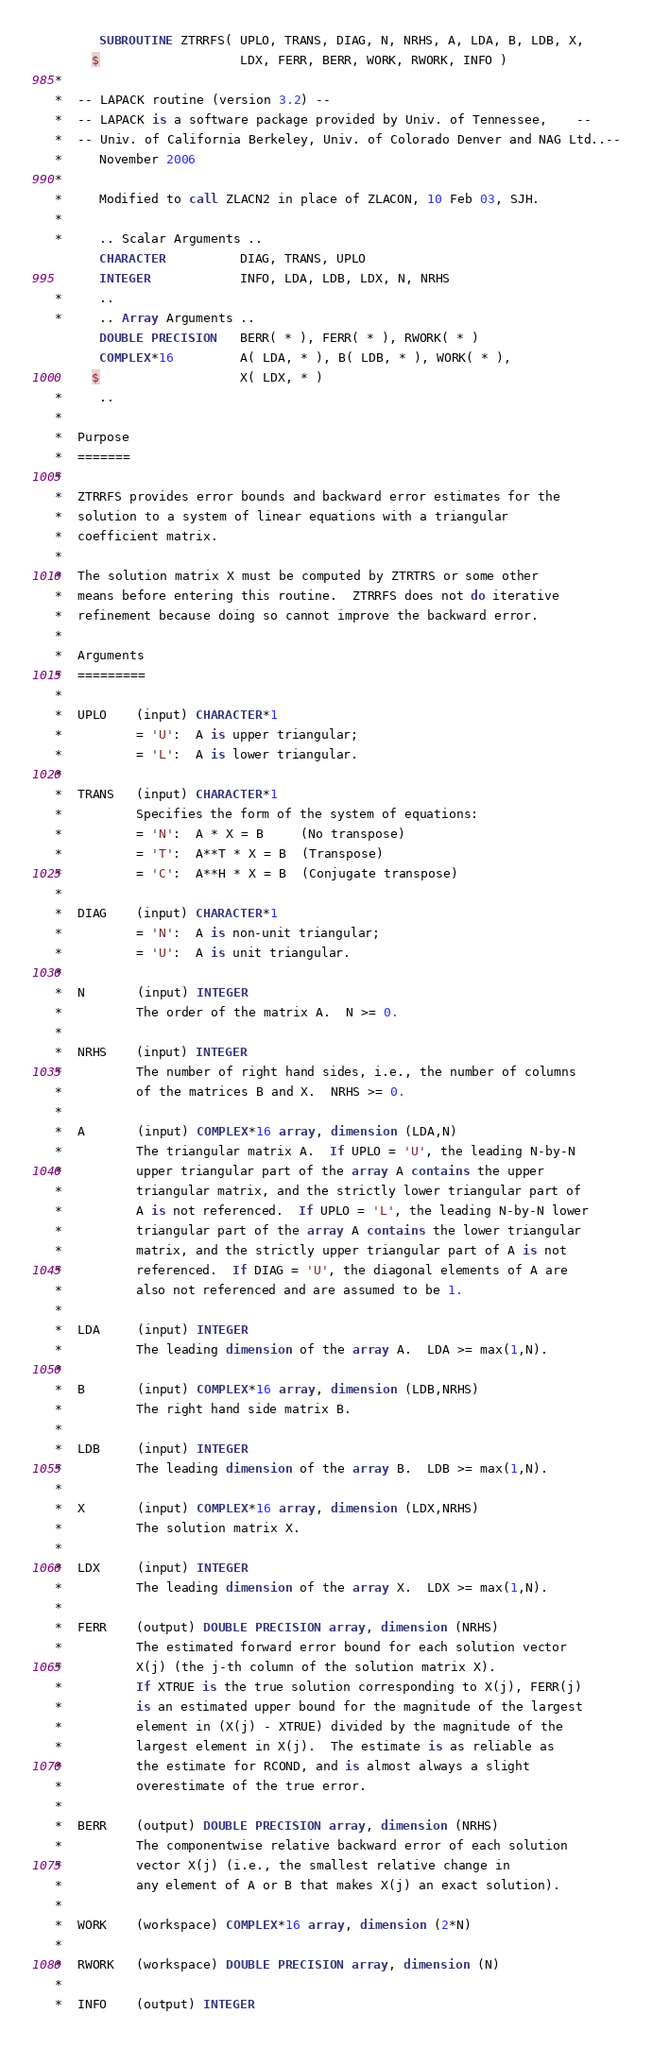Convert code to text. <code><loc_0><loc_0><loc_500><loc_500><_FORTRAN_>      SUBROUTINE ZTRRFS( UPLO, TRANS, DIAG, N, NRHS, A, LDA, B, LDB, X,
     $                   LDX, FERR, BERR, WORK, RWORK, INFO )
*
*  -- LAPACK routine (version 3.2) --
*  -- LAPACK is a software package provided by Univ. of Tennessee,    --
*  -- Univ. of California Berkeley, Univ. of Colorado Denver and NAG Ltd..--
*     November 2006
*
*     Modified to call ZLACN2 in place of ZLACON, 10 Feb 03, SJH.
*
*     .. Scalar Arguments ..
      CHARACTER          DIAG, TRANS, UPLO
      INTEGER            INFO, LDA, LDB, LDX, N, NRHS
*     ..
*     .. Array Arguments ..
      DOUBLE PRECISION   BERR( * ), FERR( * ), RWORK( * )
      COMPLEX*16         A( LDA, * ), B( LDB, * ), WORK( * ),
     $                   X( LDX, * )
*     ..
*
*  Purpose
*  =======
*
*  ZTRRFS provides error bounds and backward error estimates for the
*  solution to a system of linear equations with a triangular
*  coefficient matrix.
*
*  The solution matrix X must be computed by ZTRTRS or some other
*  means before entering this routine.  ZTRRFS does not do iterative
*  refinement because doing so cannot improve the backward error.
*
*  Arguments
*  =========
*
*  UPLO    (input) CHARACTER*1
*          = 'U':  A is upper triangular;
*          = 'L':  A is lower triangular.
*
*  TRANS   (input) CHARACTER*1
*          Specifies the form of the system of equations:
*          = 'N':  A * X = B     (No transpose)
*          = 'T':  A**T * X = B  (Transpose)
*          = 'C':  A**H * X = B  (Conjugate transpose)
*
*  DIAG    (input) CHARACTER*1
*          = 'N':  A is non-unit triangular;
*          = 'U':  A is unit triangular.
*
*  N       (input) INTEGER
*          The order of the matrix A.  N >= 0.
*
*  NRHS    (input) INTEGER
*          The number of right hand sides, i.e., the number of columns
*          of the matrices B and X.  NRHS >= 0.
*
*  A       (input) COMPLEX*16 array, dimension (LDA,N)
*          The triangular matrix A.  If UPLO = 'U', the leading N-by-N
*          upper triangular part of the array A contains the upper
*          triangular matrix, and the strictly lower triangular part of
*          A is not referenced.  If UPLO = 'L', the leading N-by-N lower
*          triangular part of the array A contains the lower triangular
*          matrix, and the strictly upper triangular part of A is not
*          referenced.  If DIAG = 'U', the diagonal elements of A are
*          also not referenced and are assumed to be 1.
*
*  LDA     (input) INTEGER
*          The leading dimension of the array A.  LDA >= max(1,N).
*
*  B       (input) COMPLEX*16 array, dimension (LDB,NRHS)
*          The right hand side matrix B.
*
*  LDB     (input) INTEGER
*          The leading dimension of the array B.  LDB >= max(1,N).
*
*  X       (input) COMPLEX*16 array, dimension (LDX,NRHS)
*          The solution matrix X.
*
*  LDX     (input) INTEGER
*          The leading dimension of the array X.  LDX >= max(1,N).
*
*  FERR    (output) DOUBLE PRECISION array, dimension (NRHS)
*          The estimated forward error bound for each solution vector
*          X(j) (the j-th column of the solution matrix X).
*          If XTRUE is the true solution corresponding to X(j), FERR(j)
*          is an estimated upper bound for the magnitude of the largest
*          element in (X(j) - XTRUE) divided by the magnitude of the
*          largest element in X(j).  The estimate is as reliable as
*          the estimate for RCOND, and is almost always a slight
*          overestimate of the true error.
*
*  BERR    (output) DOUBLE PRECISION array, dimension (NRHS)
*          The componentwise relative backward error of each solution
*          vector X(j) (i.e., the smallest relative change in
*          any element of A or B that makes X(j) an exact solution).
*
*  WORK    (workspace) COMPLEX*16 array, dimension (2*N)
*
*  RWORK   (workspace) DOUBLE PRECISION array, dimension (N)
*
*  INFO    (output) INTEGER</code> 